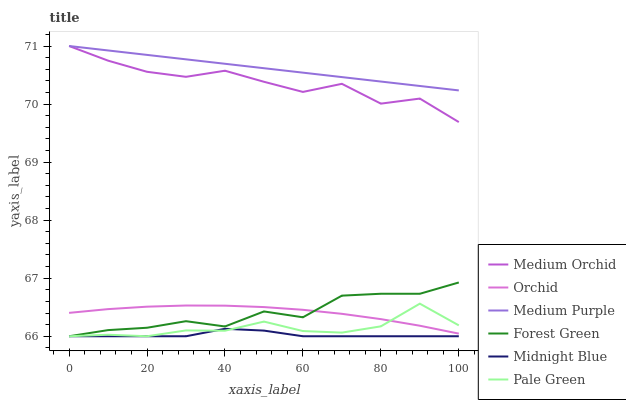Does Midnight Blue have the minimum area under the curve?
Answer yes or no. Yes. Does Medium Purple have the maximum area under the curve?
Answer yes or no. Yes. Does Medium Orchid have the minimum area under the curve?
Answer yes or no. No. Does Medium Orchid have the maximum area under the curve?
Answer yes or no. No. Is Medium Purple the smoothest?
Answer yes or no. Yes. Is Medium Orchid the roughest?
Answer yes or no. Yes. Is Medium Orchid the smoothest?
Answer yes or no. No. Is Medium Purple the roughest?
Answer yes or no. No. Does Midnight Blue have the lowest value?
Answer yes or no. Yes. Does Medium Orchid have the lowest value?
Answer yes or no. No. Does Medium Purple have the highest value?
Answer yes or no. Yes. Does Forest Green have the highest value?
Answer yes or no. No. Is Orchid less than Medium Orchid?
Answer yes or no. Yes. Is Medium Purple greater than Orchid?
Answer yes or no. Yes. Does Pale Green intersect Orchid?
Answer yes or no. Yes. Is Pale Green less than Orchid?
Answer yes or no. No. Is Pale Green greater than Orchid?
Answer yes or no. No. Does Orchid intersect Medium Orchid?
Answer yes or no. No. 